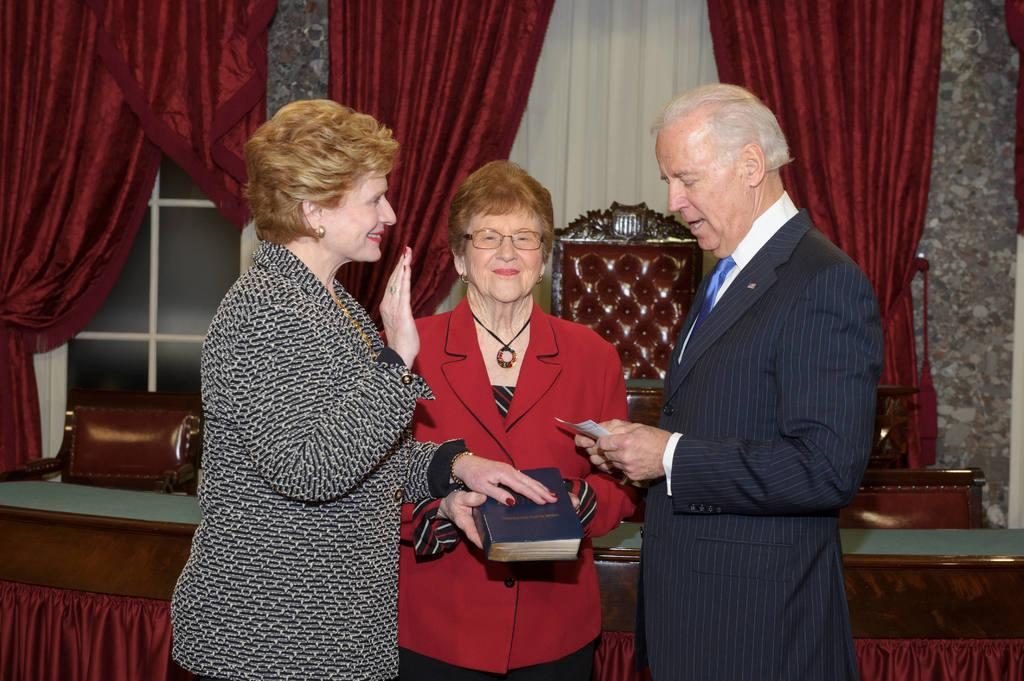How many people are in the foreground of the image? There are three people in the foreground of the image: a man and two women. What is one of the women holding in the image? One of the women is holding a book in the image. What can be seen in the background of the image? In the background of the image, there are curtains, windows, chairs, and a table. What might the people in the image be sitting on? The chairs in the background of the image suggest that the people might be sitting on them. What type of toothbrush is the man using in the image? There is no toothbrush present in the image; the man is not engaged in any activity involving a toothbrush. 